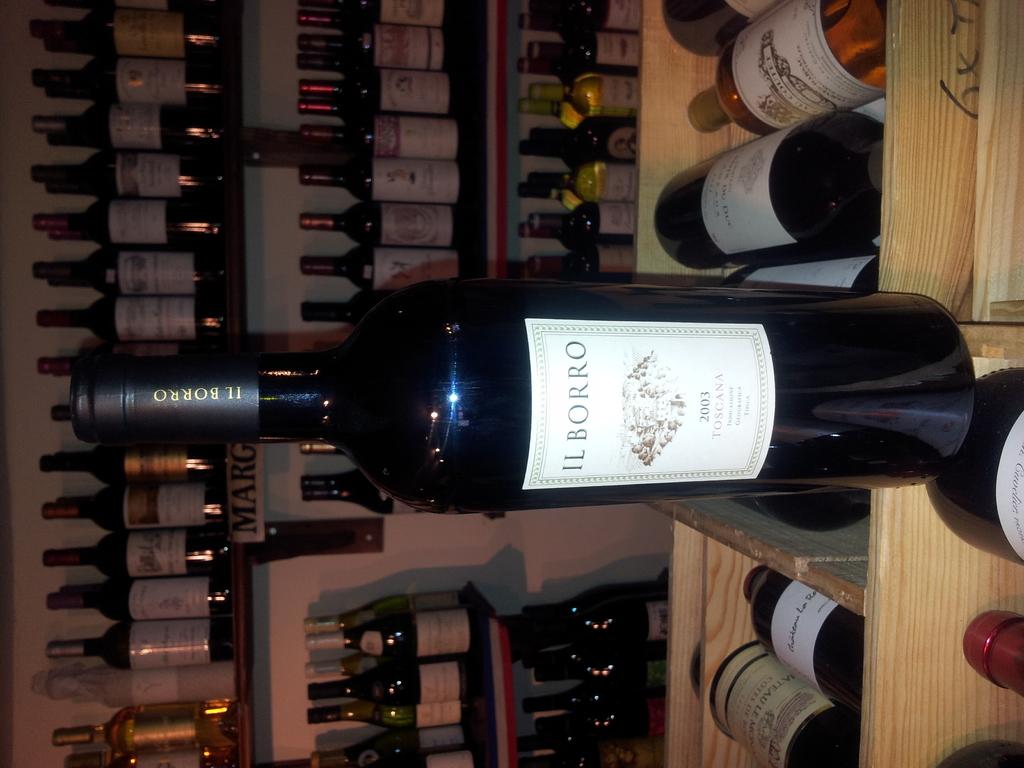What is the company that makes this wine?
Offer a very short reply. Il borro. What year was the wine made?
Your response must be concise. 2003. 